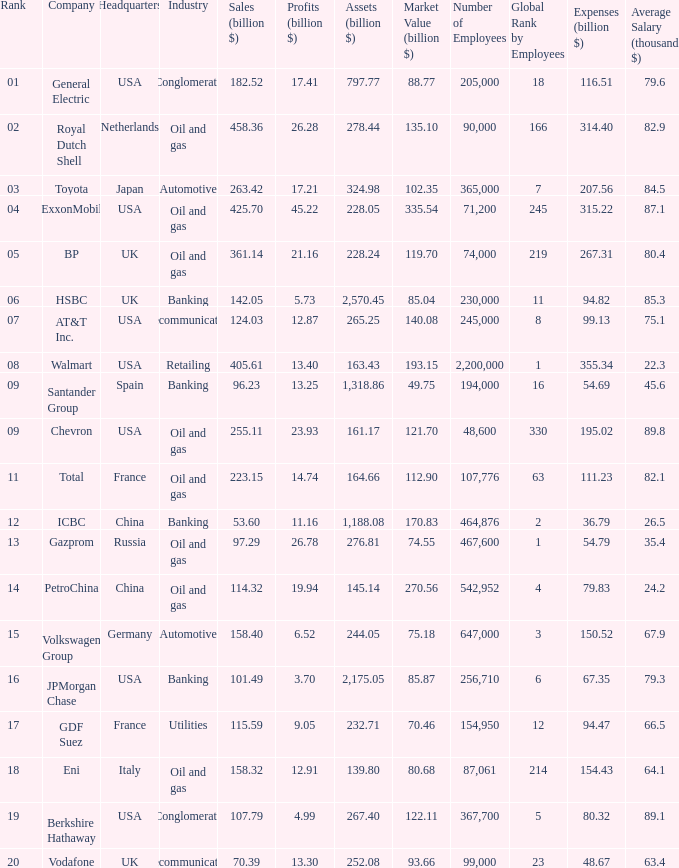How many Assets (billion $) has an Industry of oil and gas, and a Rank of 9, and a Market Value (billion $) larger than 121.7? None. 